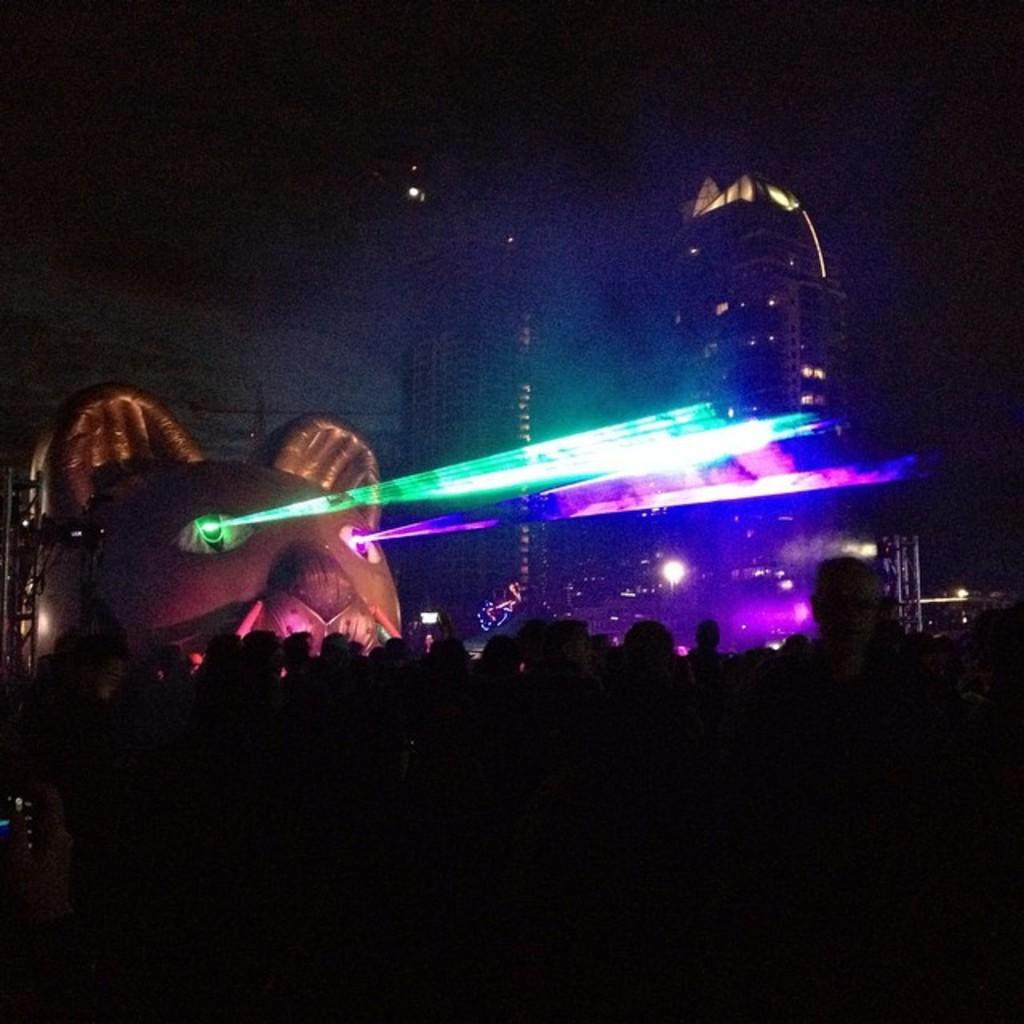What is the main subject in the image? There is a statue in the image. What feature stands out about the statue? The statue has lights on it. Who else is present in the image besides the statue? There is a group of people in the image. What type of structures can be seen in the background? There are buildings with windows in the image. What language are the trains using to communicate with each other in the image? There are no trains present in the image, so it is not possible to determine the language they might be using to communicate. 